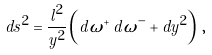<formula> <loc_0><loc_0><loc_500><loc_500>d s ^ { 2 } = \frac { l ^ { 2 } } { y ^ { 2 } } \left ( d \omega ^ { + } \, d \omega ^ { - } + d y ^ { 2 } \right ) \, ,</formula> 